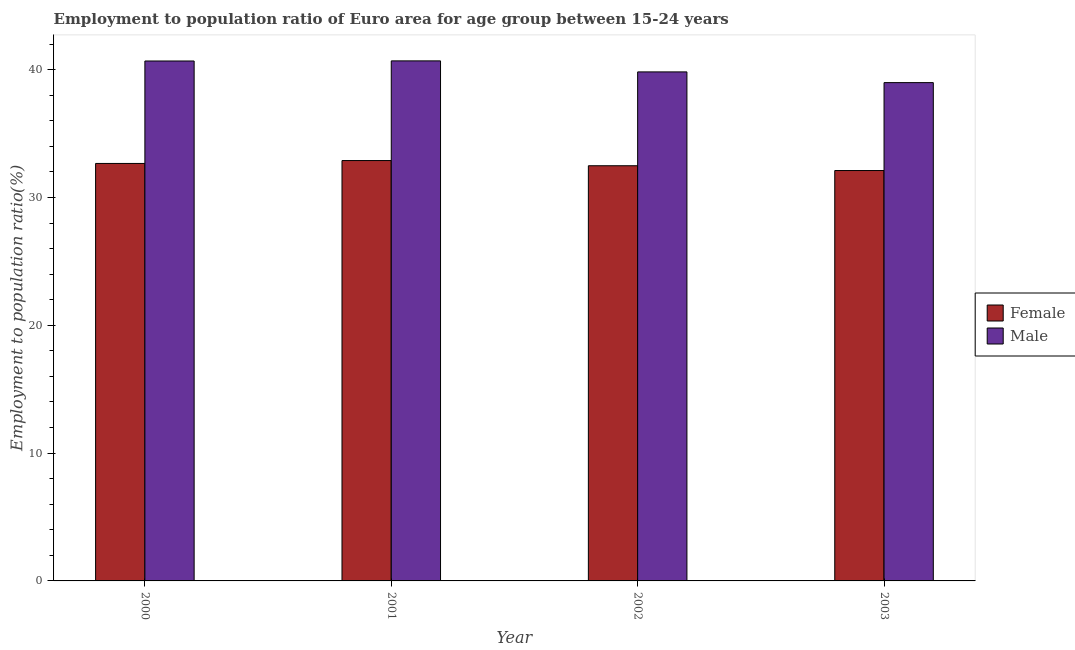How many different coloured bars are there?
Your answer should be compact. 2. How many groups of bars are there?
Offer a very short reply. 4. Are the number of bars on each tick of the X-axis equal?
Offer a terse response. Yes. How many bars are there on the 2nd tick from the left?
Offer a very short reply. 2. How many bars are there on the 1st tick from the right?
Provide a succinct answer. 2. What is the label of the 4th group of bars from the left?
Keep it short and to the point. 2003. In how many cases, is the number of bars for a given year not equal to the number of legend labels?
Your response must be concise. 0. What is the employment to population ratio(female) in 2003?
Your answer should be very brief. 32.11. Across all years, what is the maximum employment to population ratio(male)?
Your response must be concise. 40.68. Across all years, what is the minimum employment to population ratio(female)?
Offer a very short reply. 32.11. In which year was the employment to population ratio(male) maximum?
Your answer should be very brief. 2001. In which year was the employment to population ratio(female) minimum?
Your response must be concise. 2003. What is the total employment to population ratio(male) in the graph?
Make the answer very short. 160.17. What is the difference between the employment to population ratio(male) in 2000 and that in 2003?
Provide a short and direct response. 1.69. What is the difference between the employment to population ratio(female) in 2001 and the employment to population ratio(male) in 2000?
Offer a terse response. 0.23. What is the average employment to population ratio(female) per year?
Offer a terse response. 32.53. What is the ratio of the employment to population ratio(male) in 2000 to that in 2001?
Offer a very short reply. 1. What is the difference between the highest and the second highest employment to population ratio(female)?
Your response must be concise. 0.23. What is the difference between the highest and the lowest employment to population ratio(female)?
Ensure brevity in your answer.  0.78. How many years are there in the graph?
Offer a very short reply. 4. Are the values on the major ticks of Y-axis written in scientific E-notation?
Give a very brief answer. No. Where does the legend appear in the graph?
Keep it short and to the point. Center right. What is the title of the graph?
Keep it short and to the point. Employment to population ratio of Euro area for age group between 15-24 years. What is the label or title of the X-axis?
Make the answer very short. Year. What is the label or title of the Y-axis?
Offer a terse response. Employment to population ratio(%). What is the Employment to population ratio(%) of Female in 2000?
Ensure brevity in your answer.  32.66. What is the Employment to population ratio(%) in Male in 2000?
Provide a short and direct response. 40.68. What is the Employment to population ratio(%) in Female in 2001?
Your response must be concise. 32.89. What is the Employment to population ratio(%) in Male in 2001?
Your response must be concise. 40.68. What is the Employment to population ratio(%) of Female in 2002?
Offer a very short reply. 32.48. What is the Employment to population ratio(%) of Male in 2002?
Provide a short and direct response. 39.82. What is the Employment to population ratio(%) of Female in 2003?
Provide a short and direct response. 32.11. What is the Employment to population ratio(%) of Male in 2003?
Offer a very short reply. 38.98. Across all years, what is the maximum Employment to population ratio(%) of Female?
Offer a terse response. 32.89. Across all years, what is the maximum Employment to population ratio(%) of Male?
Your answer should be compact. 40.68. Across all years, what is the minimum Employment to population ratio(%) of Female?
Provide a succinct answer. 32.11. Across all years, what is the minimum Employment to population ratio(%) of Male?
Your answer should be compact. 38.98. What is the total Employment to population ratio(%) of Female in the graph?
Ensure brevity in your answer.  130.13. What is the total Employment to population ratio(%) of Male in the graph?
Make the answer very short. 160.17. What is the difference between the Employment to population ratio(%) in Female in 2000 and that in 2001?
Provide a short and direct response. -0.23. What is the difference between the Employment to population ratio(%) in Male in 2000 and that in 2001?
Make the answer very short. -0.01. What is the difference between the Employment to population ratio(%) in Female in 2000 and that in 2002?
Make the answer very short. 0.18. What is the difference between the Employment to population ratio(%) in Male in 2000 and that in 2002?
Make the answer very short. 0.85. What is the difference between the Employment to population ratio(%) in Female in 2000 and that in 2003?
Provide a short and direct response. 0.56. What is the difference between the Employment to population ratio(%) in Male in 2000 and that in 2003?
Make the answer very short. 1.69. What is the difference between the Employment to population ratio(%) of Female in 2001 and that in 2002?
Provide a succinct answer. 0.41. What is the difference between the Employment to population ratio(%) in Male in 2001 and that in 2002?
Give a very brief answer. 0.86. What is the difference between the Employment to population ratio(%) of Female in 2001 and that in 2003?
Keep it short and to the point. 0.78. What is the difference between the Employment to population ratio(%) in Male in 2001 and that in 2003?
Provide a short and direct response. 1.7. What is the difference between the Employment to population ratio(%) in Female in 2002 and that in 2003?
Your answer should be compact. 0.38. What is the difference between the Employment to population ratio(%) of Male in 2002 and that in 2003?
Your answer should be very brief. 0.84. What is the difference between the Employment to population ratio(%) of Female in 2000 and the Employment to population ratio(%) of Male in 2001?
Ensure brevity in your answer.  -8.02. What is the difference between the Employment to population ratio(%) of Female in 2000 and the Employment to population ratio(%) of Male in 2002?
Give a very brief answer. -7.16. What is the difference between the Employment to population ratio(%) in Female in 2000 and the Employment to population ratio(%) in Male in 2003?
Offer a very short reply. -6.32. What is the difference between the Employment to population ratio(%) of Female in 2001 and the Employment to population ratio(%) of Male in 2002?
Give a very brief answer. -6.93. What is the difference between the Employment to population ratio(%) in Female in 2001 and the Employment to population ratio(%) in Male in 2003?
Keep it short and to the point. -6.1. What is the difference between the Employment to population ratio(%) in Female in 2002 and the Employment to population ratio(%) in Male in 2003?
Keep it short and to the point. -6.5. What is the average Employment to population ratio(%) of Female per year?
Make the answer very short. 32.53. What is the average Employment to population ratio(%) of Male per year?
Ensure brevity in your answer.  40.04. In the year 2000, what is the difference between the Employment to population ratio(%) of Female and Employment to population ratio(%) of Male?
Make the answer very short. -8.01. In the year 2001, what is the difference between the Employment to population ratio(%) of Female and Employment to population ratio(%) of Male?
Give a very brief answer. -7.8. In the year 2002, what is the difference between the Employment to population ratio(%) in Female and Employment to population ratio(%) in Male?
Give a very brief answer. -7.34. In the year 2003, what is the difference between the Employment to population ratio(%) in Female and Employment to population ratio(%) in Male?
Your answer should be very brief. -6.88. What is the ratio of the Employment to population ratio(%) in Female in 2000 to that in 2001?
Give a very brief answer. 0.99. What is the ratio of the Employment to population ratio(%) of Male in 2000 to that in 2002?
Offer a very short reply. 1.02. What is the ratio of the Employment to population ratio(%) of Female in 2000 to that in 2003?
Provide a short and direct response. 1.02. What is the ratio of the Employment to population ratio(%) of Male in 2000 to that in 2003?
Your answer should be very brief. 1.04. What is the ratio of the Employment to population ratio(%) of Female in 2001 to that in 2002?
Provide a short and direct response. 1.01. What is the ratio of the Employment to population ratio(%) of Male in 2001 to that in 2002?
Provide a short and direct response. 1.02. What is the ratio of the Employment to population ratio(%) in Female in 2001 to that in 2003?
Offer a very short reply. 1.02. What is the ratio of the Employment to population ratio(%) of Male in 2001 to that in 2003?
Your response must be concise. 1.04. What is the ratio of the Employment to population ratio(%) of Female in 2002 to that in 2003?
Provide a succinct answer. 1.01. What is the ratio of the Employment to population ratio(%) in Male in 2002 to that in 2003?
Offer a very short reply. 1.02. What is the difference between the highest and the second highest Employment to population ratio(%) of Female?
Your response must be concise. 0.23. What is the difference between the highest and the second highest Employment to population ratio(%) in Male?
Provide a succinct answer. 0.01. What is the difference between the highest and the lowest Employment to population ratio(%) of Female?
Keep it short and to the point. 0.78. What is the difference between the highest and the lowest Employment to population ratio(%) of Male?
Your answer should be very brief. 1.7. 